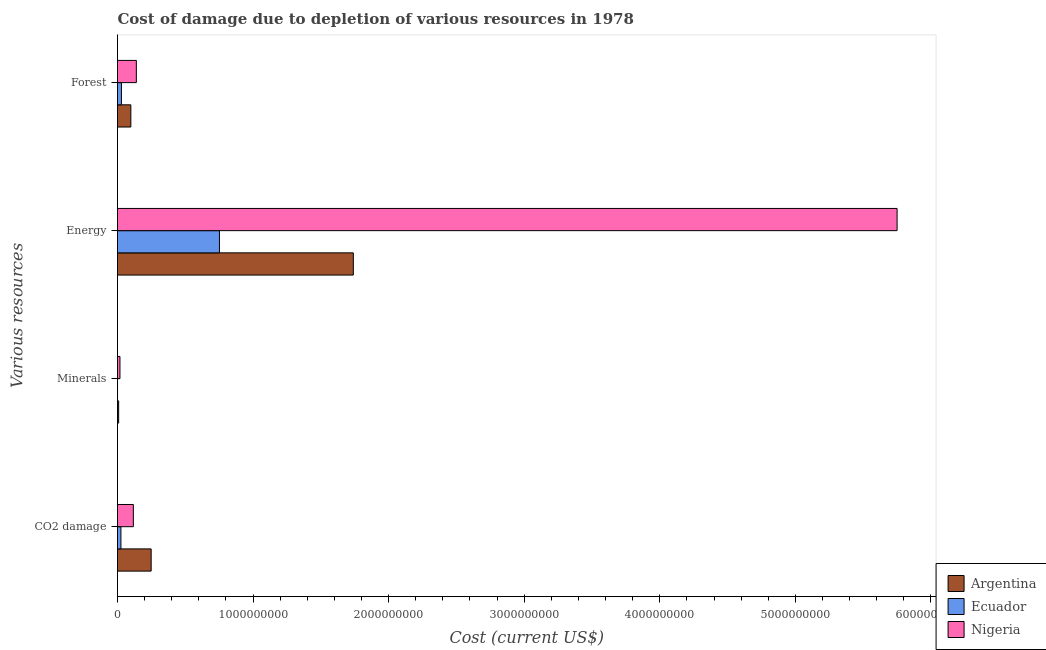How many groups of bars are there?
Offer a terse response. 4. Are the number of bars per tick equal to the number of legend labels?
Offer a terse response. Yes. Are the number of bars on each tick of the Y-axis equal?
Provide a succinct answer. Yes. How many bars are there on the 2nd tick from the top?
Your answer should be compact. 3. How many bars are there on the 4th tick from the bottom?
Offer a terse response. 3. What is the label of the 3rd group of bars from the top?
Ensure brevity in your answer.  Minerals. What is the cost of damage due to depletion of energy in Argentina?
Your answer should be very brief. 1.74e+09. Across all countries, what is the maximum cost of damage due to depletion of forests?
Provide a short and direct response. 1.39e+08. Across all countries, what is the minimum cost of damage due to depletion of energy?
Give a very brief answer. 7.52e+08. In which country was the cost of damage due to depletion of minerals maximum?
Your response must be concise. Nigeria. In which country was the cost of damage due to depletion of coal minimum?
Your response must be concise. Ecuador. What is the total cost of damage due to depletion of coal in the graph?
Your answer should be compact. 3.90e+08. What is the difference between the cost of damage due to depletion of energy in Argentina and that in Nigeria?
Keep it short and to the point. -4.01e+09. What is the difference between the cost of damage due to depletion of minerals in Nigeria and the cost of damage due to depletion of forests in Argentina?
Ensure brevity in your answer.  -8.03e+07. What is the average cost of damage due to depletion of coal per country?
Offer a very short reply. 1.30e+08. What is the difference between the cost of damage due to depletion of forests and cost of damage due to depletion of coal in Nigeria?
Offer a very short reply. 2.22e+07. What is the ratio of the cost of damage due to depletion of forests in Nigeria to that in Argentina?
Keep it short and to the point. 1.41. Is the cost of damage due to depletion of forests in Nigeria less than that in Ecuador?
Keep it short and to the point. No. What is the difference between the highest and the second highest cost of damage due to depletion of energy?
Offer a very short reply. 4.01e+09. What is the difference between the highest and the lowest cost of damage due to depletion of minerals?
Keep it short and to the point. 1.79e+07. In how many countries, is the cost of damage due to depletion of forests greater than the average cost of damage due to depletion of forests taken over all countries?
Provide a short and direct response. 2. What does the 2nd bar from the top in Energy represents?
Your answer should be compact. Ecuador. Is it the case that in every country, the sum of the cost of damage due to depletion of coal and cost of damage due to depletion of minerals is greater than the cost of damage due to depletion of energy?
Keep it short and to the point. No. How many bars are there?
Your answer should be compact. 12. Are all the bars in the graph horizontal?
Provide a succinct answer. Yes. How many countries are there in the graph?
Your answer should be compact. 3. Does the graph contain any zero values?
Your response must be concise. No. Where does the legend appear in the graph?
Ensure brevity in your answer.  Bottom right. How many legend labels are there?
Make the answer very short. 3. What is the title of the graph?
Your response must be concise. Cost of damage due to depletion of various resources in 1978 . What is the label or title of the X-axis?
Offer a terse response. Cost (current US$). What is the label or title of the Y-axis?
Keep it short and to the point. Various resources. What is the Cost (current US$) of Argentina in CO2 damage?
Your answer should be compact. 2.48e+08. What is the Cost (current US$) in Ecuador in CO2 damage?
Your answer should be compact. 2.52e+07. What is the Cost (current US$) of Nigeria in CO2 damage?
Your answer should be very brief. 1.17e+08. What is the Cost (current US$) in Argentina in Minerals?
Offer a very short reply. 8.54e+06. What is the Cost (current US$) in Ecuador in Minerals?
Give a very brief answer. 1.14e+05. What is the Cost (current US$) in Nigeria in Minerals?
Give a very brief answer. 1.80e+07. What is the Cost (current US$) of Argentina in Energy?
Offer a terse response. 1.74e+09. What is the Cost (current US$) in Ecuador in Energy?
Make the answer very short. 7.52e+08. What is the Cost (current US$) in Nigeria in Energy?
Offer a very short reply. 5.75e+09. What is the Cost (current US$) in Argentina in Forest?
Provide a short and direct response. 9.83e+07. What is the Cost (current US$) of Ecuador in Forest?
Make the answer very short. 2.89e+07. What is the Cost (current US$) in Nigeria in Forest?
Provide a short and direct response. 1.39e+08. Across all Various resources, what is the maximum Cost (current US$) of Argentina?
Ensure brevity in your answer.  1.74e+09. Across all Various resources, what is the maximum Cost (current US$) in Ecuador?
Ensure brevity in your answer.  7.52e+08. Across all Various resources, what is the maximum Cost (current US$) of Nigeria?
Make the answer very short. 5.75e+09. Across all Various resources, what is the minimum Cost (current US$) of Argentina?
Your answer should be compact. 8.54e+06. Across all Various resources, what is the minimum Cost (current US$) of Ecuador?
Make the answer very short. 1.14e+05. Across all Various resources, what is the minimum Cost (current US$) in Nigeria?
Make the answer very short. 1.80e+07. What is the total Cost (current US$) of Argentina in the graph?
Offer a very short reply. 2.09e+09. What is the total Cost (current US$) in Ecuador in the graph?
Give a very brief answer. 8.06e+08. What is the total Cost (current US$) in Nigeria in the graph?
Your response must be concise. 6.02e+09. What is the difference between the Cost (current US$) in Argentina in CO2 damage and that in Minerals?
Your answer should be very brief. 2.40e+08. What is the difference between the Cost (current US$) in Ecuador in CO2 damage and that in Minerals?
Make the answer very short. 2.51e+07. What is the difference between the Cost (current US$) in Nigeria in CO2 damage and that in Minerals?
Give a very brief answer. 9.88e+07. What is the difference between the Cost (current US$) of Argentina in CO2 damage and that in Energy?
Your response must be concise. -1.49e+09. What is the difference between the Cost (current US$) in Ecuador in CO2 damage and that in Energy?
Offer a very short reply. -7.27e+08. What is the difference between the Cost (current US$) of Nigeria in CO2 damage and that in Energy?
Make the answer very short. -5.63e+09. What is the difference between the Cost (current US$) of Argentina in CO2 damage and that in Forest?
Your response must be concise. 1.50e+08. What is the difference between the Cost (current US$) in Ecuador in CO2 damage and that in Forest?
Offer a very short reply. -3.71e+06. What is the difference between the Cost (current US$) in Nigeria in CO2 damage and that in Forest?
Give a very brief answer. -2.22e+07. What is the difference between the Cost (current US$) of Argentina in Minerals and that in Energy?
Offer a very short reply. -1.73e+09. What is the difference between the Cost (current US$) of Ecuador in Minerals and that in Energy?
Provide a short and direct response. -7.52e+08. What is the difference between the Cost (current US$) in Nigeria in Minerals and that in Energy?
Provide a short and direct response. -5.73e+09. What is the difference between the Cost (current US$) in Argentina in Minerals and that in Forest?
Offer a very short reply. -8.98e+07. What is the difference between the Cost (current US$) of Ecuador in Minerals and that in Forest?
Your answer should be compact. -2.88e+07. What is the difference between the Cost (current US$) of Nigeria in Minerals and that in Forest?
Provide a short and direct response. -1.21e+08. What is the difference between the Cost (current US$) of Argentina in Energy and that in Forest?
Your response must be concise. 1.64e+09. What is the difference between the Cost (current US$) in Ecuador in Energy and that in Forest?
Your answer should be compact. 7.23e+08. What is the difference between the Cost (current US$) of Nigeria in Energy and that in Forest?
Offer a terse response. 5.61e+09. What is the difference between the Cost (current US$) in Argentina in CO2 damage and the Cost (current US$) in Ecuador in Minerals?
Offer a terse response. 2.48e+08. What is the difference between the Cost (current US$) of Argentina in CO2 damage and the Cost (current US$) of Nigeria in Minerals?
Keep it short and to the point. 2.30e+08. What is the difference between the Cost (current US$) in Ecuador in CO2 damage and the Cost (current US$) in Nigeria in Minerals?
Your answer should be very brief. 7.18e+06. What is the difference between the Cost (current US$) in Argentina in CO2 damage and the Cost (current US$) in Ecuador in Energy?
Keep it short and to the point. -5.04e+08. What is the difference between the Cost (current US$) in Argentina in CO2 damage and the Cost (current US$) in Nigeria in Energy?
Provide a succinct answer. -5.50e+09. What is the difference between the Cost (current US$) of Ecuador in CO2 damage and the Cost (current US$) of Nigeria in Energy?
Keep it short and to the point. -5.73e+09. What is the difference between the Cost (current US$) in Argentina in CO2 damage and the Cost (current US$) in Ecuador in Forest?
Ensure brevity in your answer.  2.19e+08. What is the difference between the Cost (current US$) in Argentina in CO2 damage and the Cost (current US$) in Nigeria in Forest?
Your response must be concise. 1.09e+08. What is the difference between the Cost (current US$) in Ecuador in CO2 damage and the Cost (current US$) in Nigeria in Forest?
Provide a short and direct response. -1.14e+08. What is the difference between the Cost (current US$) in Argentina in Minerals and the Cost (current US$) in Ecuador in Energy?
Your answer should be very brief. -7.43e+08. What is the difference between the Cost (current US$) in Argentina in Minerals and the Cost (current US$) in Nigeria in Energy?
Your answer should be very brief. -5.74e+09. What is the difference between the Cost (current US$) in Ecuador in Minerals and the Cost (current US$) in Nigeria in Energy?
Your answer should be compact. -5.75e+09. What is the difference between the Cost (current US$) of Argentina in Minerals and the Cost (current US$) of Ecuador in Forest?
Make the answer very short. -2.04e+07. What is the difference between the Cost (current US$) of Argentina in Minerals and the Cost (current US$) of Nigeria in Forest?
Your answer should be compact. -1.30e+08. What is the difference between the Cost (current US$) of Ecuador in Minerals and the Cost (current US$) of Nigeria in Forest?
Offer a terse response. -1.39e+08. What is the difference between the Cost (current US$) in Argentina in Energy and the Cost (current US$) in Ecuador in Forest?
Give a very brief answer. 1.71e+09. What is the difference between the Cost (current US$) in Argentina in Energy and the Cost (current US$) in Nigeria in Forest?
Offer a terse response. 1.60e+09. What is the difference between the Cost (current US$) of Ecuador in Energy and the Cost (current US$) of Nigeria in Forest?
Offer a terse response. 6.13e+08. What is the average Cost (current US$) in Argentina per Various resources?
Your answer should be compact. 5.24e+08. What is the average Cost (current US$) of Ecuador per Various resources?
Your answer should be compact. 2.02e+08. What is the average Cost (current US$) in Nigeria per Various resources?
Your answer should be compact. 1.51e+09. What is the difference between the Cost (current US$) of Argentina and Cost (current US$) of Ecuador in CO2 damage?
Your answer should be compact. 2.23e+08. What is the difference between the Cost (current US$) in Argentina and Cost (current US$) in Nigeria in CO2 damage?
Ensure brevity in your answer.  1.31e+08. What is the difference between the Cost (current US$) in Ecuador and Cost (current US$) in Nigeria in CO2 damage?
Ensure brevity in your answer.  -9.16e+07. What is the difference between the Cost (current US$) of Argentina and Cost (current US$) of Ecuador in Minerals?
Make the answer very short. 8.43e+06. What is the difference between the Cost (current US$) in Argentina and Cost (current US$) in Nigeria in Minerals?
Your answer should be compact. -9.49e+06. What is the difference between the Cost (current US$) of Ecuador and Cost (current US$) of Nigeria in Minerals?
Keep it short and to the point. -1.79e+07. What is the difference between the Cost (current US$) of Argentina and Cost (current US$) of Ecuador in Energy?
Provide a succinct answer. 9.87e+08. What is the difference between the Cost (current US$) in Argentina and Cost (current US$) in Nigeria in Energy?
Offer a very short reply. -4.01e+09. What is the difference between the Cost (current US$) of Ecuador and Cost (current US$) of Nigeria in Energy?
Keep it short and to the point. -5.00e+09. What is the difference between the Cost (current US$) in Argentina and Cost (current US$) in Ecuador in Forest?
Provide a short and direct response. 6.94e+07. What is the difference between the Cost (current US$) of Argentina and Cost (current US$) of Nigeria in Forest?
Offer a terse response. -4.06e+07. What is the difference between the Cost (current US$) in Ecuador and Cost (current US$) in Nigeria in Forest?
Your response must be concise. -1.10e+08. What is the ratio of the Cost (current US$) in Argentina in CO2 damage to that in Minerals?
Your response must be concise. 29.06. What is the ratio of the Cost (current US$) of Ecuador in CO2 damage to that in Minerals?
Your answer should be compact. 220.28. What is the ratio of the Cost (current US$) of Nigeria in CO2 damage to that in Minerals?
Give a very brief answer. 6.48. What is the ratio of the Cost (current US$) of Argentina in CO2 damage to that in Energy?
Offer a very short reply. 0.14. What is the ratio of the Cost (current US$) of Ecuador in CO2 damage to that in Energy?
Your answer should be compact. 0.03. What is the ratio of the Cost (current US$) in Nigeria in CO2 damage to that in Energy?
Your answer should be very brief. 0.02. What is the ratio of the Cost (current US$) in Argentina in CO2 damage to that in Forest?
Keep it short and to the point. 2.52. What is the ratio of the Cost (current US$) in Ecuador in CO2 damage to that in Forest?
Keep it short and to the point. 0.87. What is the ratio of the Cost (current US$) in Nigeria in CO2 damage to that in Forest?
Offer a terse response. 0.84. What is the ratio of the Cost (current US$) of Argentina in Minerals to that in Energy?
Your answer should be very brief. 0. What is the ratio of the Cost (current US$) in Nigeria in Minerals to that in Energy?
Provide a succinct answer. 0. What is the ratio of the Cost (current US$) of Argentina in Minerals to that in Forest?
Your answer should be very brief. 0.09. What is the ratio of the Cost (current US$) of Ecuador in Minerals to that in Forest?
Ensure brevity in your answer.  0. What is the ratio of the Cost (current US$) in Nigeria in Minerals to that in Forest?
Ensure brevity in your answer.  0.13. What is the ratio of the Cost (current US$) in Argentina in Energy to that in Forest?
Make the answer very short. 17.69. What is the ratio of the Cost (current US$) in Ecuador in Energy to that in Forest?
Ensure brevity in your answer.  26. What is the ratio of the Cost (current US$) in Nigeria in Energy to that in Forest?
Your answer should be compact. 41.38. What is the difference between the highest and the second highest Cost (current US$) in Argentina?
Keep it short and to the point. 1.49e+09. What is the difference between the highest and the second highest Cost (current US$) in Ecuador?
Offer a very short reply. 7.23e+08. What is the difference between the highest and the second highest Cost (current US$) in Nigeria?
Make the answer very short. 5.61e+09. What is the difference between the highest and the lowest Cost (current US$) in Argentina?
Your answer should be compact. 1.73e+09. What is the difference between the highest and the lowest Cost (current US$) of Ecuador?
Ensure brevity in your answer.  7.52e+08. What is the difference between the highest and the lowest Cost (current US$) of Nigeria?
Make the answer very short. 5.73e+09. 